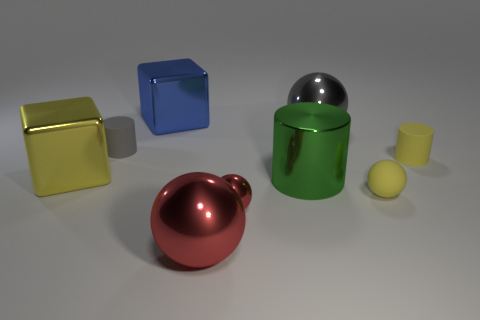Is there another red metal object of the same shape as the tiny red shiny object?
Provide a succinct answer. Yes. What number of things are either yellow things in front of the big green metal cylinder or large gray metallic things?
Offer a terse response. 2. Are there more tiny yellow rubber cylinders than green rubber cylinders?
Keep it short and to the point. Yes. Is there a blue metal block that has the same size as the matte sphere?
Your answer should be very brief. No. How many objects are large shiny cubes on the left side of the large blue thing or large objects behind the gray cylinder?
Make the answer very short. 3. What color is the cylinder that is right of the sphere that is behind the big green cylinder?
Provide a short and direct response. Yellow. There is a small object that is the same material as the green cylinder; what is its color?
Offer a terse response. Red. What number of tiny spheres are the same color as the big cylinder?
Offer a very short reply. 0. What number of things are blue spheres or blue metallic things?
Your answer should be compact. 1. There is a gray metal thing that is the same size as the blue metallic cube; what is its shape?
Your answer should be very brief. Sphere. 